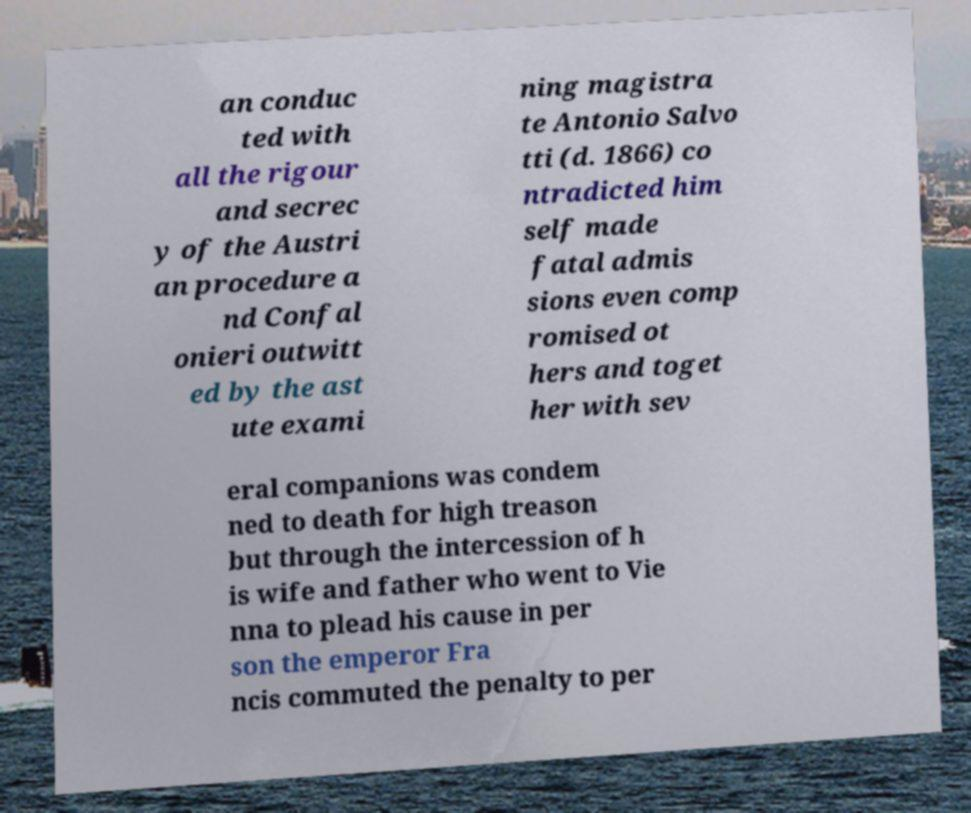Please read and relay the text visible in this image. What does it say? an conduc ted with all the rigour and secrec y of the Austri an procedure a nd Confal onieri outwitt ed by the ast ute exami ning magistra te Antonio Salvo tti (d. 1866) co ntradicted him self made fatal admis sions even comp romised ot hers and toget her with sev eral companions was condem ned to death for high treason but through the intercession of h is wife and father who went to Vie nna to plead his cause in per son the emperor Fra ncis commuted the penalty to per 